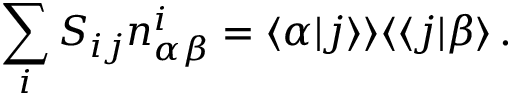<formula> <loc_0><loc_0><loc_500><loc_500>\sum _ { i } S _ { i j } n _ { \alpha \beta } ^ { i } = \langle \alpha | j \rangle \rangle \langle \langle j | \beta \rangle \, .</formula> 